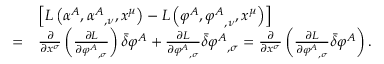Convert formula to latex. <formula><loc_0><loc_0><loc_500><loc_500>{ \begin{array} { r l } & { \left [ L \left ( \alpha ^ { A } , { \alpha ^ { A } } _ { , \nu } , x ^ { \mu } \right ) - L \left ( \varphi ^ { A } , { \varphi ^ { A } } _ { , \nu } , x ^ { \mu } \right ) \right ] } \\ { = } & { { \frac { \partial } { \partial x ^ { \sigma } } } \left ( { \frac { \partial L } { \partial { \varphi ^ { A } } _ { , \sigma } } } \right ) { \bar { \delta } } \varphi ^ { A } + { \frac { \partial L } { \partial { \varphi ^ { A } } _ { , \sigma } } } { \bar { \delta } } { \varphi ^ { A } } _ { , \sigma } = { \frac { \partial } { \partial x ^ { \sigma } } } \left ( { \frac { \partial L } { \partial { \varphi ^ { A } } _ { , \sigma } } } { \bar { \delta } } \varphi ^ { A } \right ) . } \end{array} }</formula> 